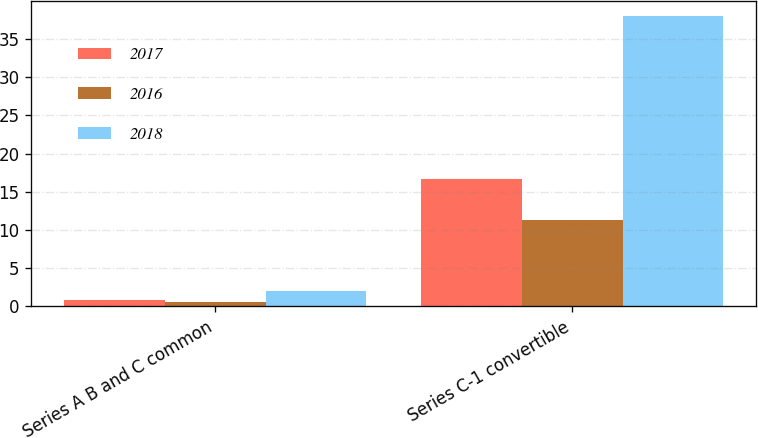<chart> <loc_0><loc_0><loc_500><loc_500><stacked_bar_chart><ecel><fcel>Series A B and C common<fcel>Series C-1 convertible<nl><fcel>2017<fcel>0.86<fcel>16.65<nl><fcel>2016<fcel>0.59<fcel>11.33<nl><fcel>2018<fcel>1.97<fcel>38.07<nl></chart> 